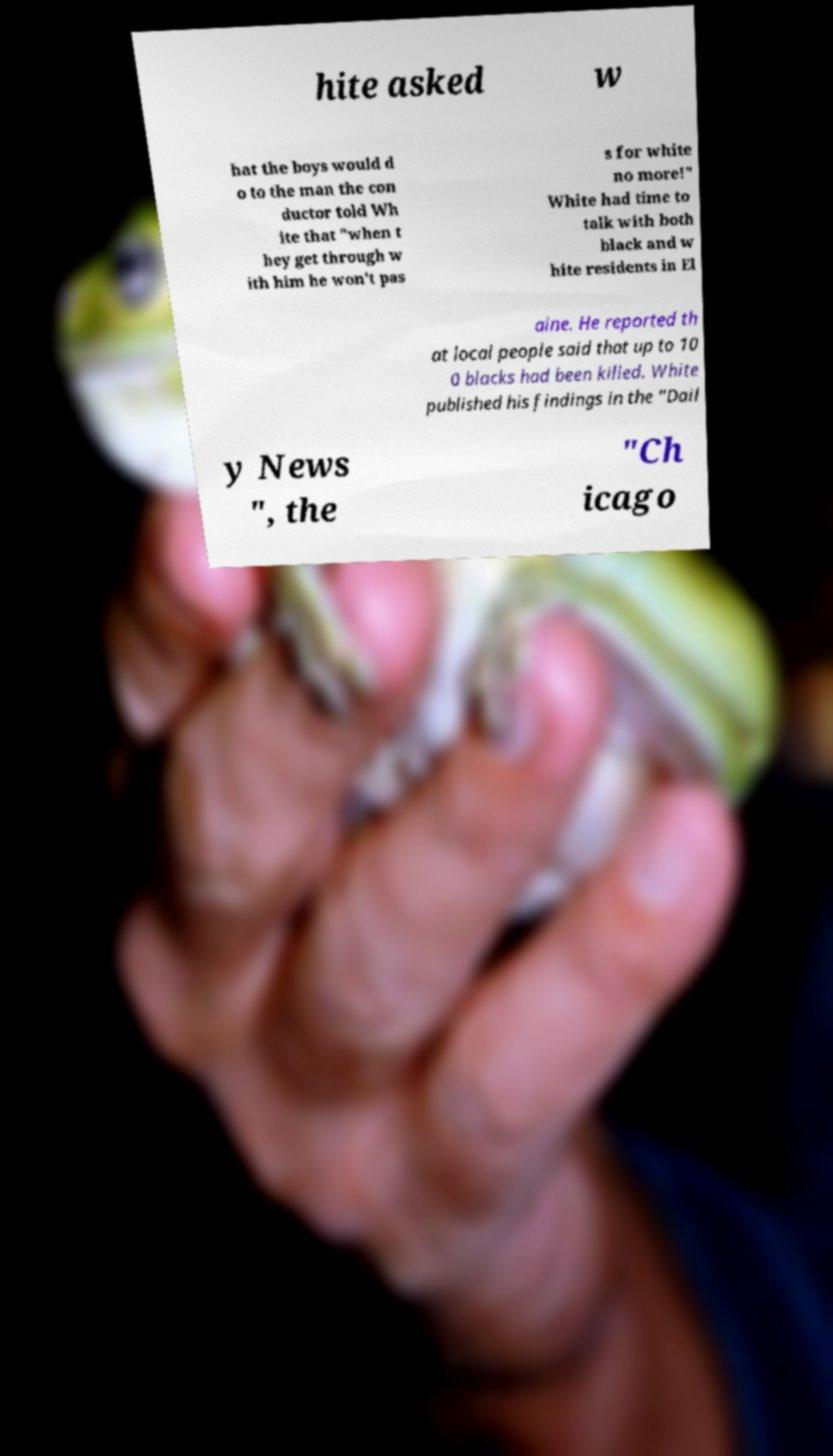There's text embedded in this image that I need extracted. Can you transcribe it verbatim? hite asked w hat the boys would d o to the man the con ductor told Wh ite that "when t hey get through w ith him he won't pas s for white no more!" White had time to talk with both black and w hite residents in El aine. He reported th at local people said that up to 10 0 blacks had been killed. White published his findings in the "Dail y News ", the "Ch icago 